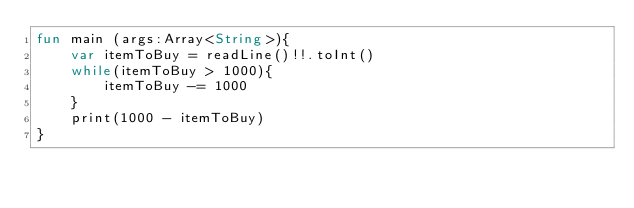Convert code to text. <code><loc_0><loc_0><loc_500><loc_500><_Kotlin_>fun main (args:Array<String>){
    var itemToBuy = readLine()!!.toInt()
    while(itemToBuy > 1000){
        itemToBuy -= 1000
    }
    print(1000 - itemToBuy)
}</code> 